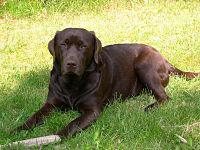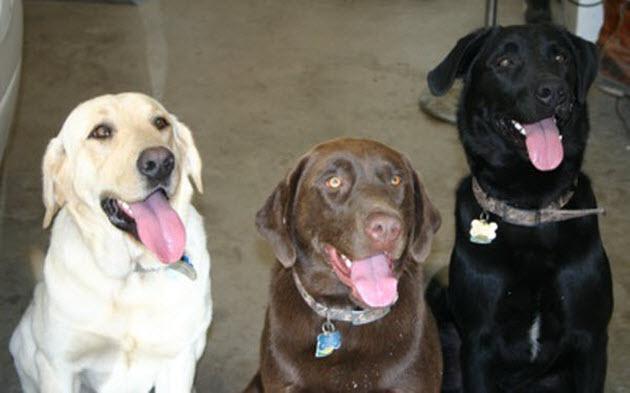The first image is the image on the left, the second image is the image on the right. For the images displayed, is the sentence "There is a total of six dogs." factually correct? Answer yes or no. No. 